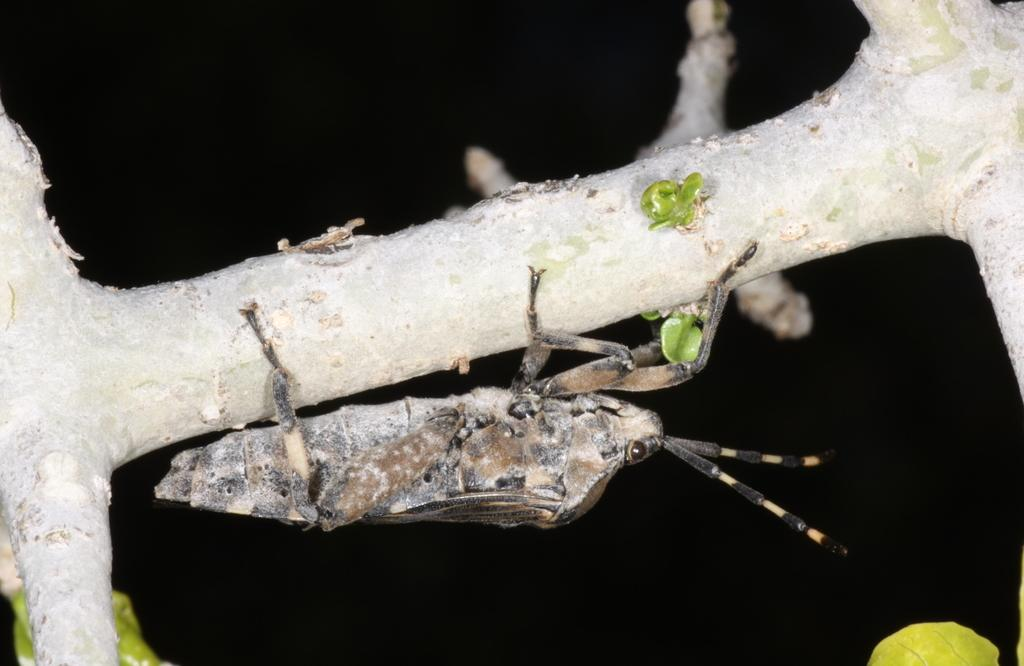What is the main subject in the center of the image? There is an insect in the center of the image. What type of objects can be seen in the image? There are wooden objects in the image. What type of vegetation is present in the image? Green leaves are present in the image. How would you describe the lighting in the image? The background of the image is very dark. What type of van is parked next to the insect in the image? There is no van present in the image; it only features an insect, wooden objects, green leaves, and a dark background. 